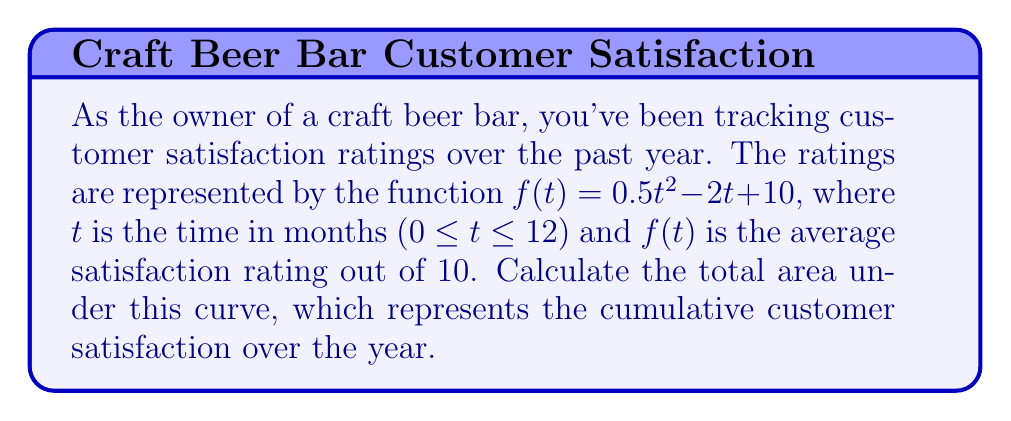Show me your answer to this math problem. To find the area under the curve, we need to integrate the function $f(t)$ from $t=0$ to $t=12$. Here's how we do it step-by-step:

1) The integral we need to evaluate is:

   $$\int_0^{12} (0.5t^2 - 2t + 10) dt$$

2) Integrate each term separately:
   
   $$\int 0.5t^2 dt = \frac{0.5t^3}{3}$$
   $$\int -2t dt = -t^2$$
   $$\int 10 dt = 10t$$

3) Combine these results:

   $$\left[\frac{0.5t^3}{3} - t^2 + 10t\right]_0^{12}$$

4) Evaluate at the upper and lower bounds:

   $$\left(\frac{0.5(12^3)}{3} - 12^2 + 10(12)\right) - \left(\frac{0.5(0^3)}{3} - 0^2 + 10(0)\right)$$

5) Simplify:

   $$\left(288 - 144 + 120\right) - (0)$$

6) Calculate the final result:

   $$264$$
Answer: 264 satisfaction-months 